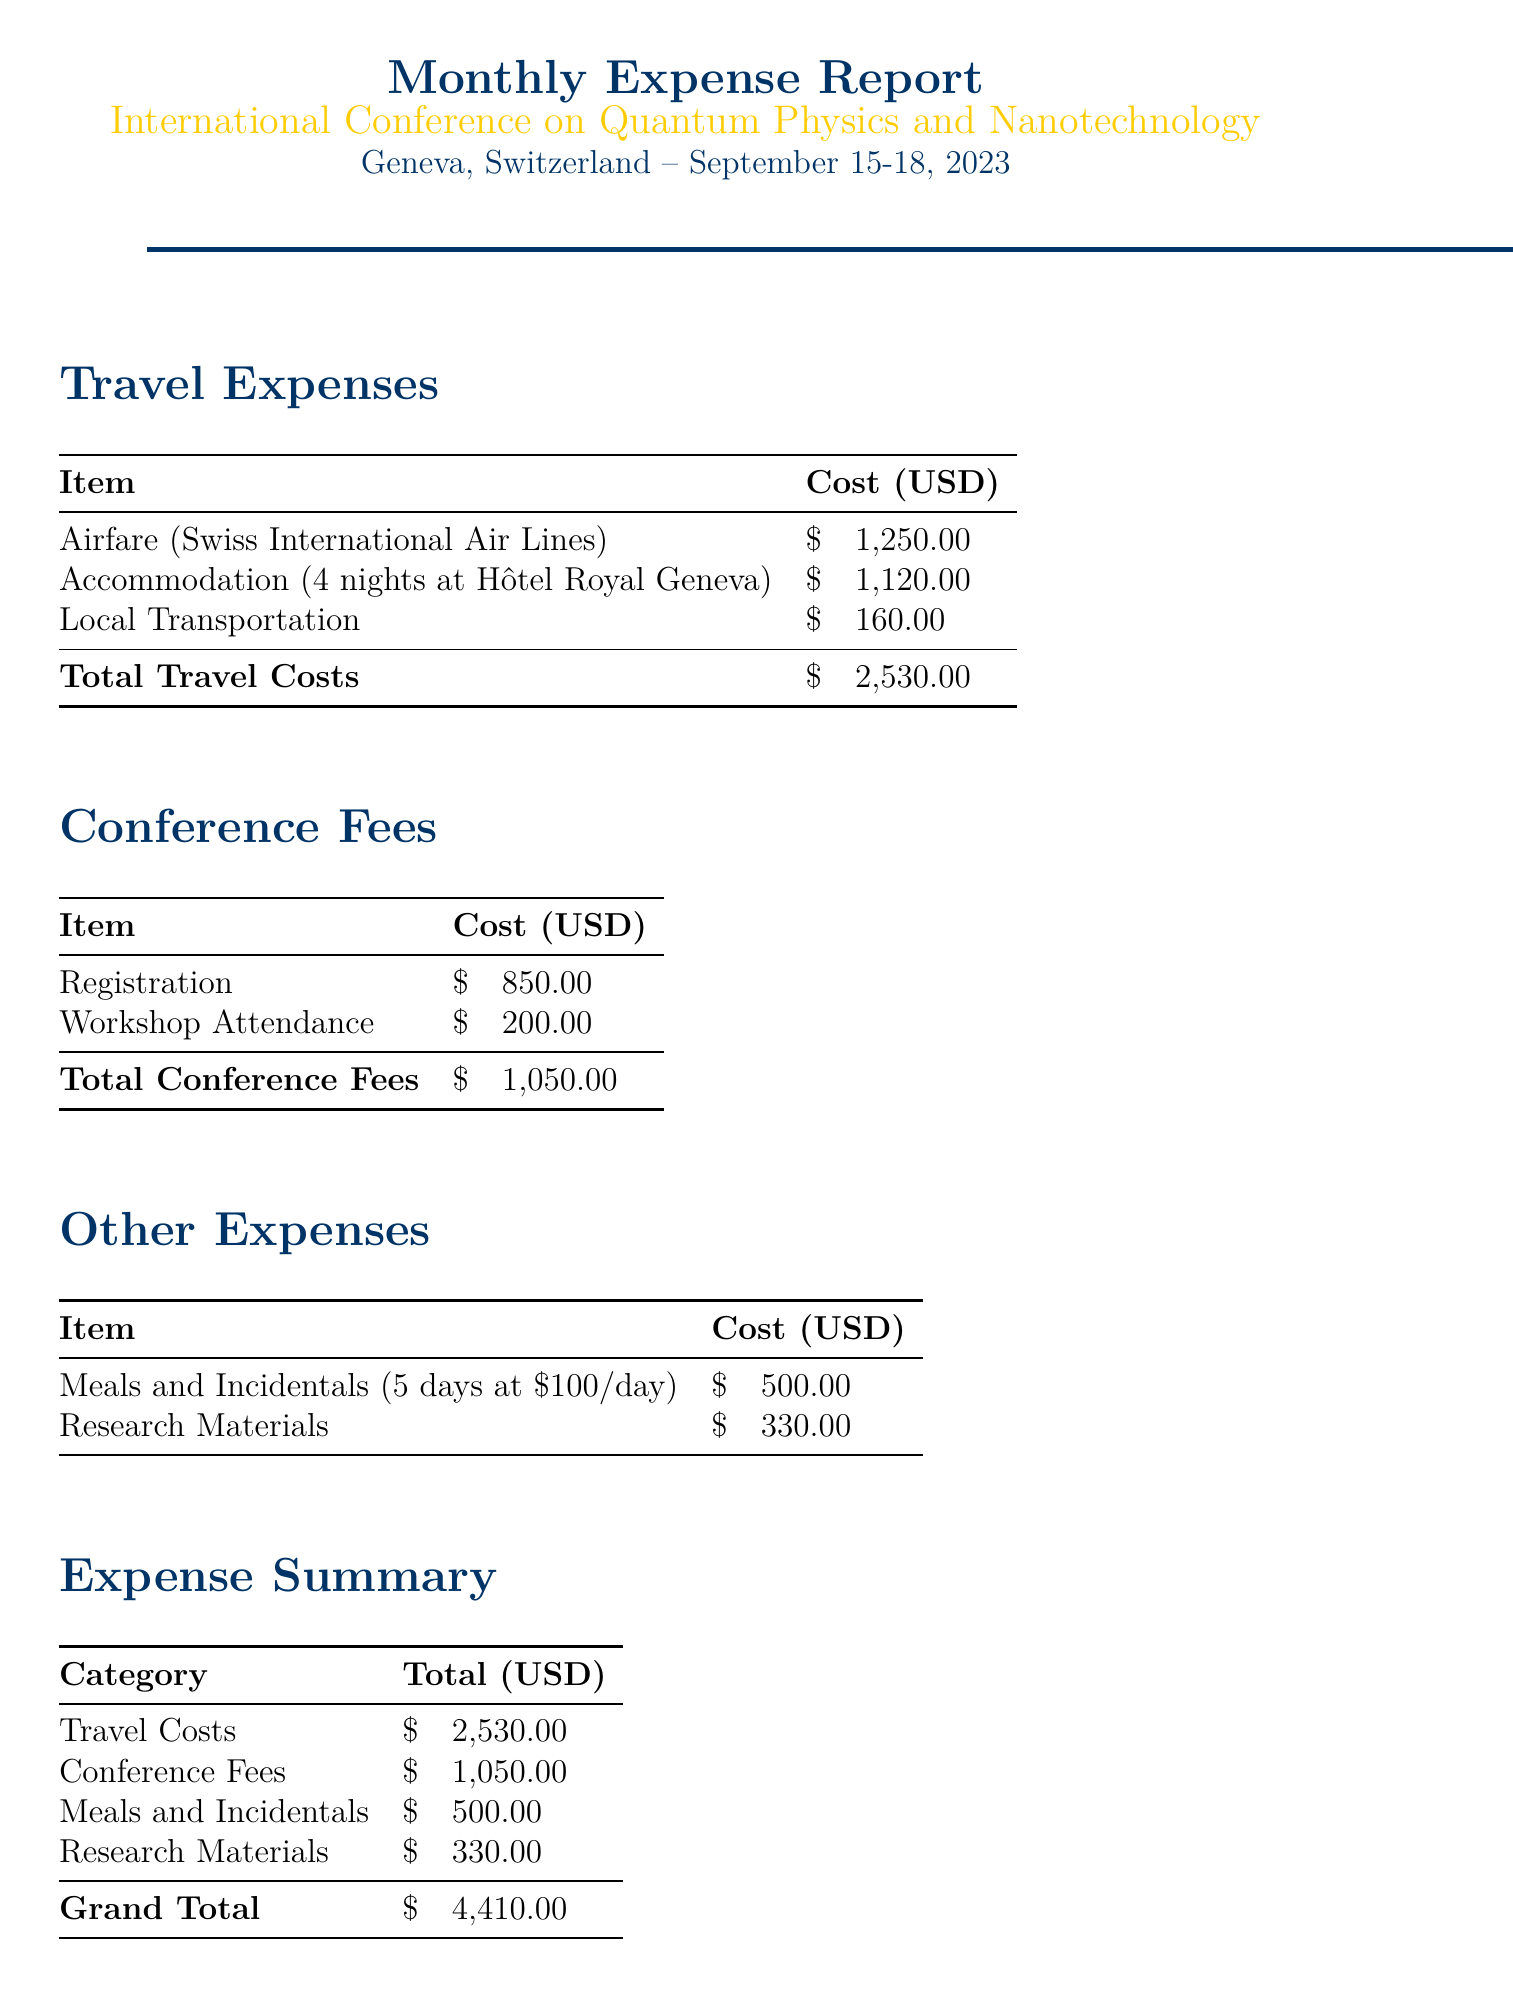What is the name of the conference? The name of the conference can be found in the conference details section, which states "International Conference on Quantum Physics and Nanotechnology."
Answer: International Conference on Quantum Physics and Nanotechnology What are the dates of the conference? The dates can be found in the conference details, which indicate September 15-18, 2023.
Answer: September 15-18, 2023 What is the total travel cost? The total travel cost is provided in the expense summary section as $2530.00.
Answer: $2530.00 How much was spent on meals and incidentals? The amount spent on meals and incidentals is specified in the expense summary as $500.00.
Answer: $500.00 What is the cost for accommodation per night? The document states the cost per night for accommodation is $280.00.
Answer: $280.00 What was the total cost for research materials? The total cost for research materials is detailed in the expense summary as $330.00.
Answer: $330.00 What is the grand total for all expenses? The grand total for all expenses is recorded in the expense summary section as $4410.00.
Answer: $4410.00 Who is quoted regarding the importance of attending international conferences? The quote is attributed to "A renowned scientist" in the document.
Answer: A renowned scientist What is the airline used for airfare? The document mentions "Swiss International Air Lines" as the airline for airfare.
Answer: Swiss International Air Lines How many nights was accommodation booked for? The document specifies that accommodation was booked for 4 nights.
Answer: 4 nights 